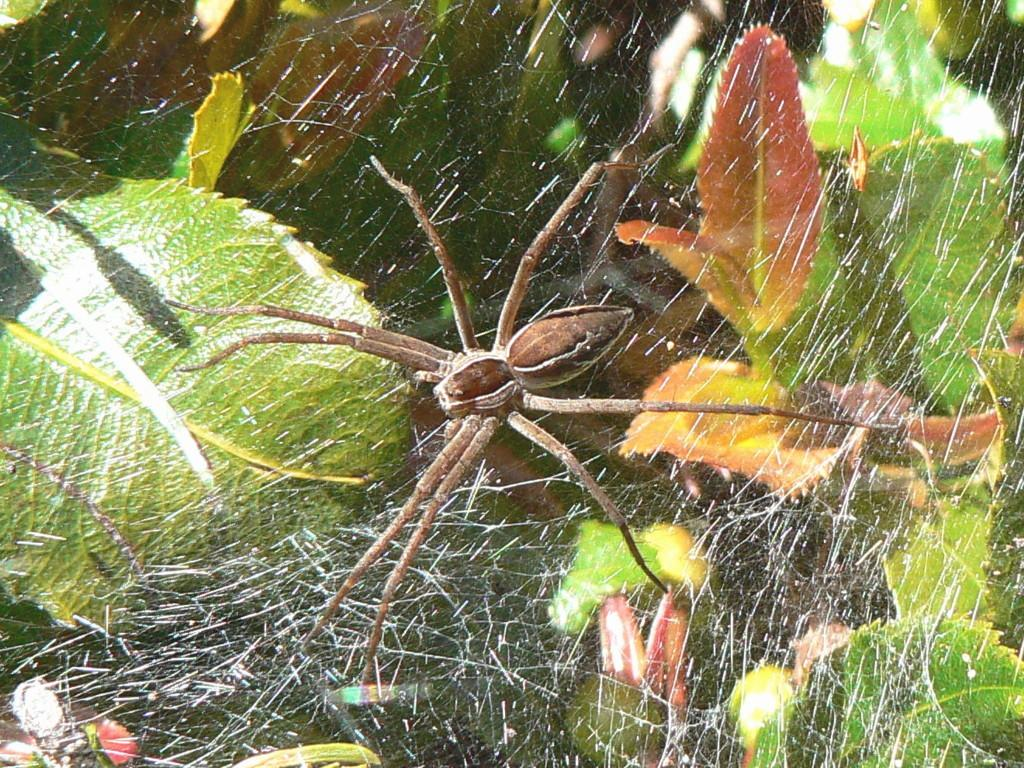What is the main subject in the center of the image? There is a spider in the center of the image. What is the spider resting on? The spider is on a web. What can be seen in the background of the image? There are leaves in the background of the image. What type of insurance policy is the spider considering in the image? There is no indication of insurance or any financial matters in the image; it features a spider on a web with leaves in the background. 